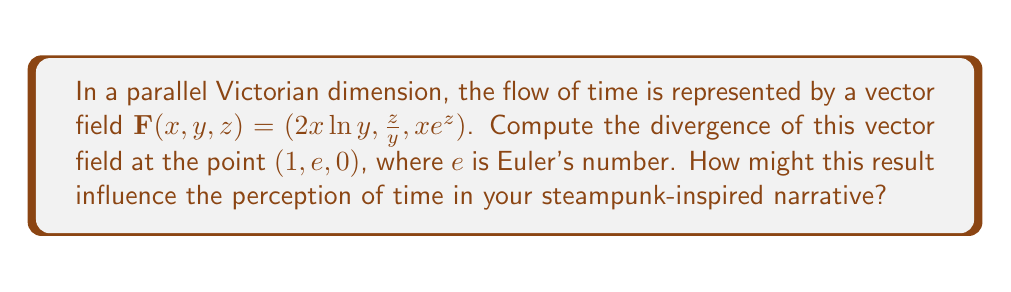Could you help me with this problem? To compute the divergence of the vector field, we need to follow these steps:

1) The divergence of a vector field $\mathbf{F}(x,y,z) = (F_1, F_2, F_3)$ is given by:

   $$\text{div}\mathbf{F} = \nabla \cdot \mathbf{F} = \frac{\partial F_1}{\partial x} + \frac{\partial F_2}{\partial y} + \frac{\partial F_3}{\partial z}$$

2) For our vector field $\mathbf{F}(x,y,z) = (2x\ln y, \frac{z}{y}, xe^z)$, we need to compute:

   $$\frac{\partial}{\partial x}(2x\ln y) + \frac{\partial}{\partial y}(\frac{z}{y}) + \frac{\partial}{\partial z}(xe^z)$$

3) Let's compute each partial derivative:

   $\frac{\partial}{\partial x}(2x\ln y) = 2\ln y$
   
   $\frac{\partial}{\partial y}(\frac{z}{y}) = -\frac{z}{y^2}$
   
   $\frac{\partial}{\partial z}(xe^z) = xe^z$

4) Therefore, the divergence is:

   $$\text{div}\mathbf{F} = 2\ln y - \frac{z}{y^2} + xe^z$$

5) Now, we need to evaluate this at the point $(1,e,0)$:

   $$\text{div}\mathbf{F}(1,e,0) = 2\ln e - \frac{0}{e^2} + 1e^0 = 2 + 1 = 3$$

This result indicates that the flow of time in this Victorian dimension is expanding at the given point, which could lead to interesting narrative possibilities in a steampunk setting.
Answer: 3 